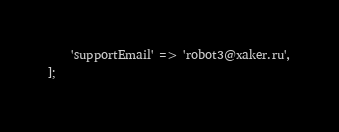Convert code to text. <code><loc_0><loc_0><loc_500><loc_500><_PHP_>    'supportEmail' => 'robot3@xaker.ru',
];
</code> 